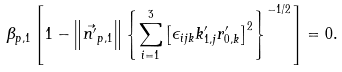Convert formula to latex. <formula><loc_0><loc_0><loc_500><loc_500>\beta _ { p , 1 } \left [ 1 - \left \| \vec { n ^ { \prime } } _ { p , 1 } \right \| \left \{ \sum _ { i = 1 } ^ { 3 } \left [ \epsilon _ { i j k } k ^ { \prime } _ { 1 , j } r ^ { \prime } _ { 0 , k } \right ] ^ { 2 } \right \} ^ { - 1 / 2 } \right ] & = 0 .</formula> 